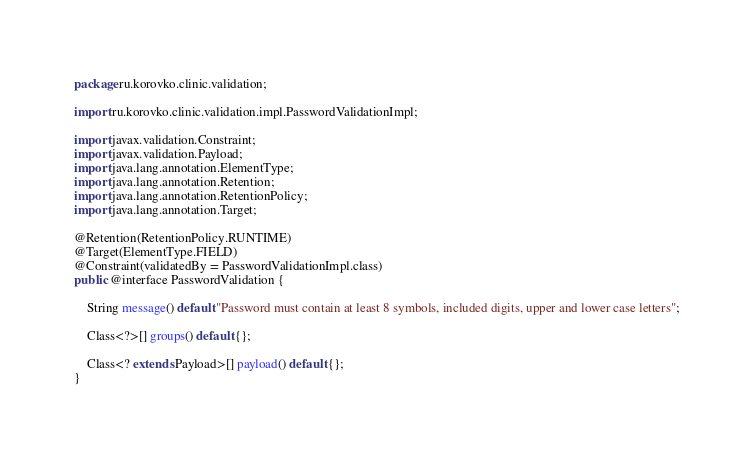<code> <loc_0><loc_0><loc_500><loc_500><_Java_>package ru.korovko.clinic.validation;

import ru.korovko.clinic.validation.impl.PasswordValidationImpl;

import javax.validation.Constraint;
import javax.validation.Payload;
import java.lang.annotation.ElementType;
import java.lang.annotation.Retention;
import java.lang.annotation.RetentionPolicy;
import java.lang.annotation.Target;

@Retention(RetentionPolicy.RUNTIME)
@Target(ElementType.FIELD)
@Constraint(validatedBy = PasswordValidationImpl.class)
public @interface PasswordValidation {

    String message() default "Password must contain at least 8 symbols, included digits, upper and lower case letters";

    Class<?>[] groups() default {};

    Class<? extends Payload>[] payload() default {};
}</code> 